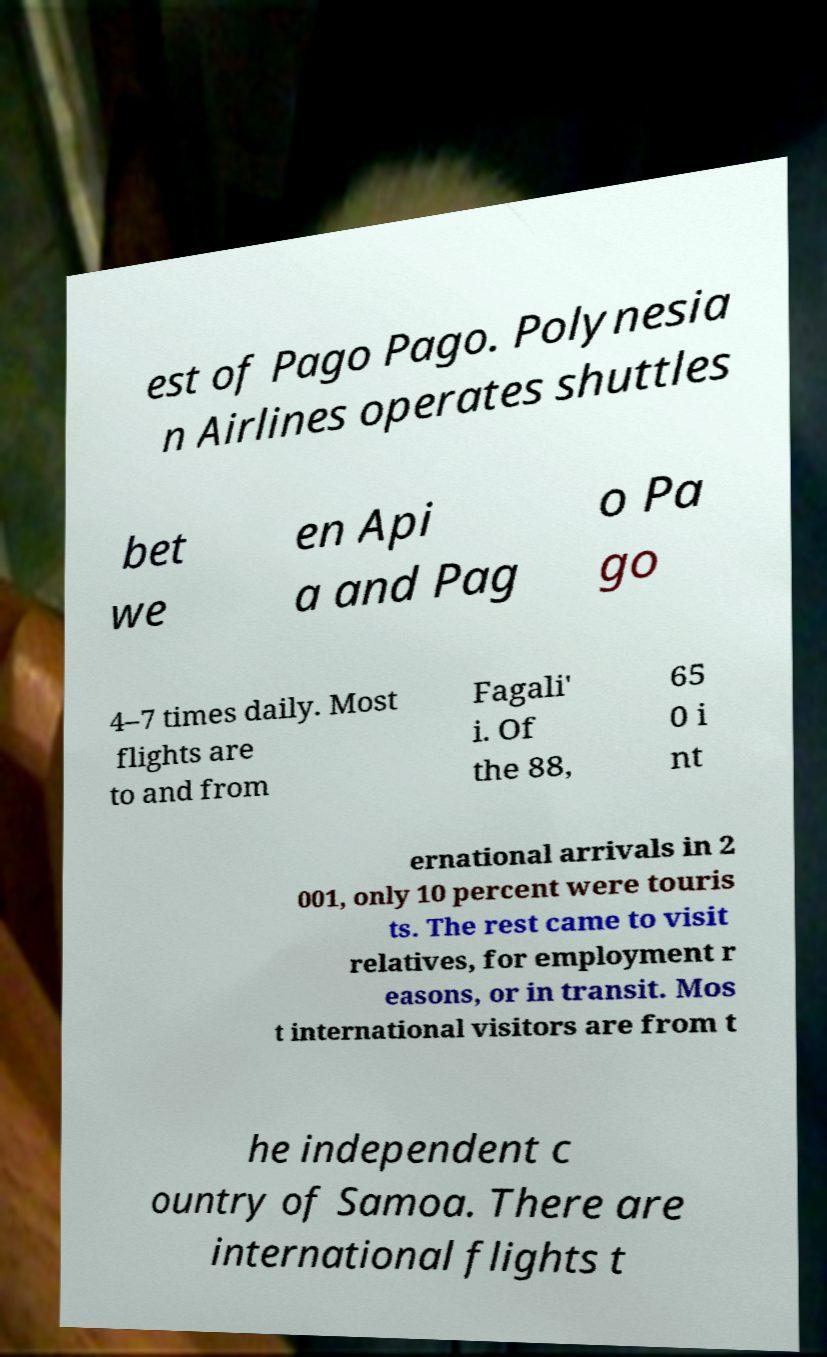Could you assist in decoding the text presented in this image and type it out clearly? est of Pago Pago. Polynesia n Airlines operates shuttles bet we en Api a and Pag o Pa go 4–7 times daily. Most flights are to and from Fagali' i. Of the 88, 65 0 i nt ernational arrivals in 2 001, only 10 percent were touris ts. The rest came to visit relatives, for employment r easons, or in transit. Mos t international visitors are from t he independent c ountry of Samoa. There are international flights t 